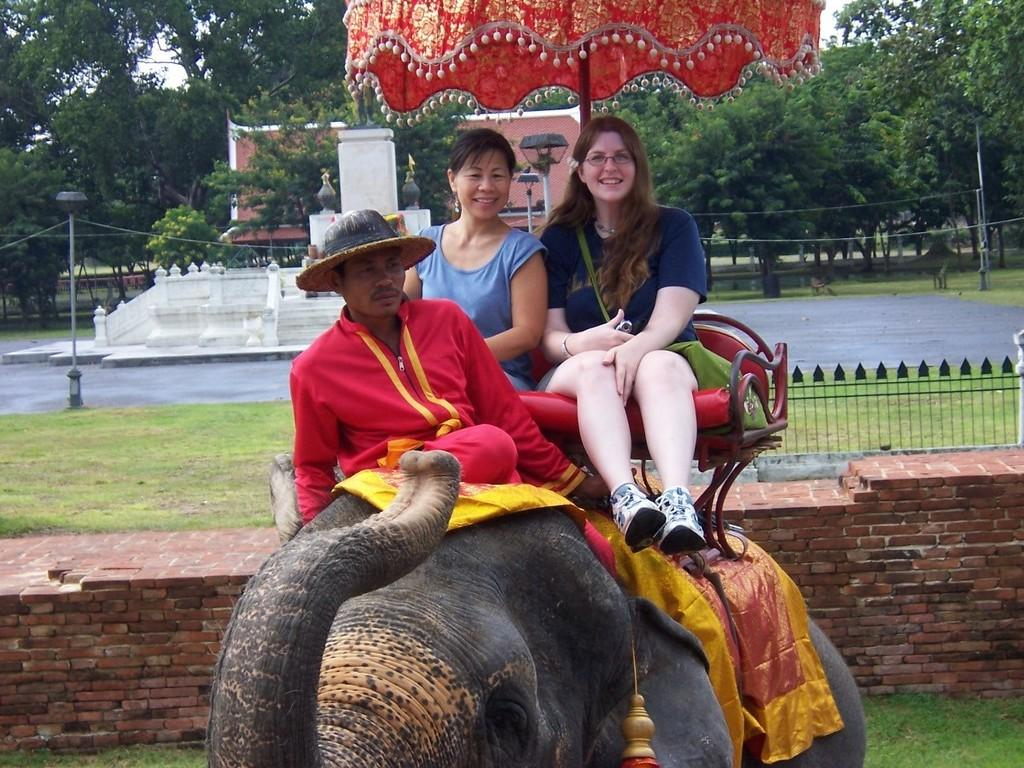How many people are in the image? There are three persons in the image. What is one person doing in the image? One person is riding an elephant (Mahout). How many people are sitting on the elephant? Two persons are sitting on the elephant. What can be seen in the background of the image? There are trees in the background of the image. What type of collar is the visitor wearing in the image? There is no visitor present in the image, and therefore no collar can be observed. What arithmetic problem are the persons on the elephant solving in the image? There is no indication in the image that the persons on the elephant are solving any arithmetic problems. 